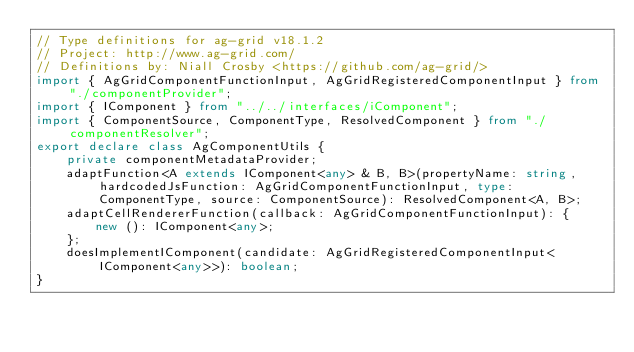<code> <loc_0><loc_0><loc_500><loc_500><_TypeScript_>// Type definitions for ag-grid v18.1.2
// Project: http://www.ag-grid.com/
// Definitions by: Niall Crosby <https://github.com/ag-grid/>
import { AgGridComponentFunctionInput, AgGridRegisteredComponentInput } from "./componentProvider";
import { IComponent } from "../../interfaces/iComponent";
import { ComponentSource, ComponentType, ResolvedComponent } from "./componentResolver";
export declare class AgComponentUtils {
    private componentMetadataProvider;
    adaptFunction<A extends IComponent<any> & B, B>(propertyName: string, hardcodedJsFunction: AgGridComponentFunctionInput, type: ComponentType, source: ComponentSource): ResolvedComponent<A, B>;
    adaptCellRendererFunction(callback: AgGridComponentFunctionInput): {
        new (): IComponent<any>;
    };
    doesImplementIComponent(candidate: AgGridRegisteredComponentInput<IComponent<any>>): boolean;
}
</code> 